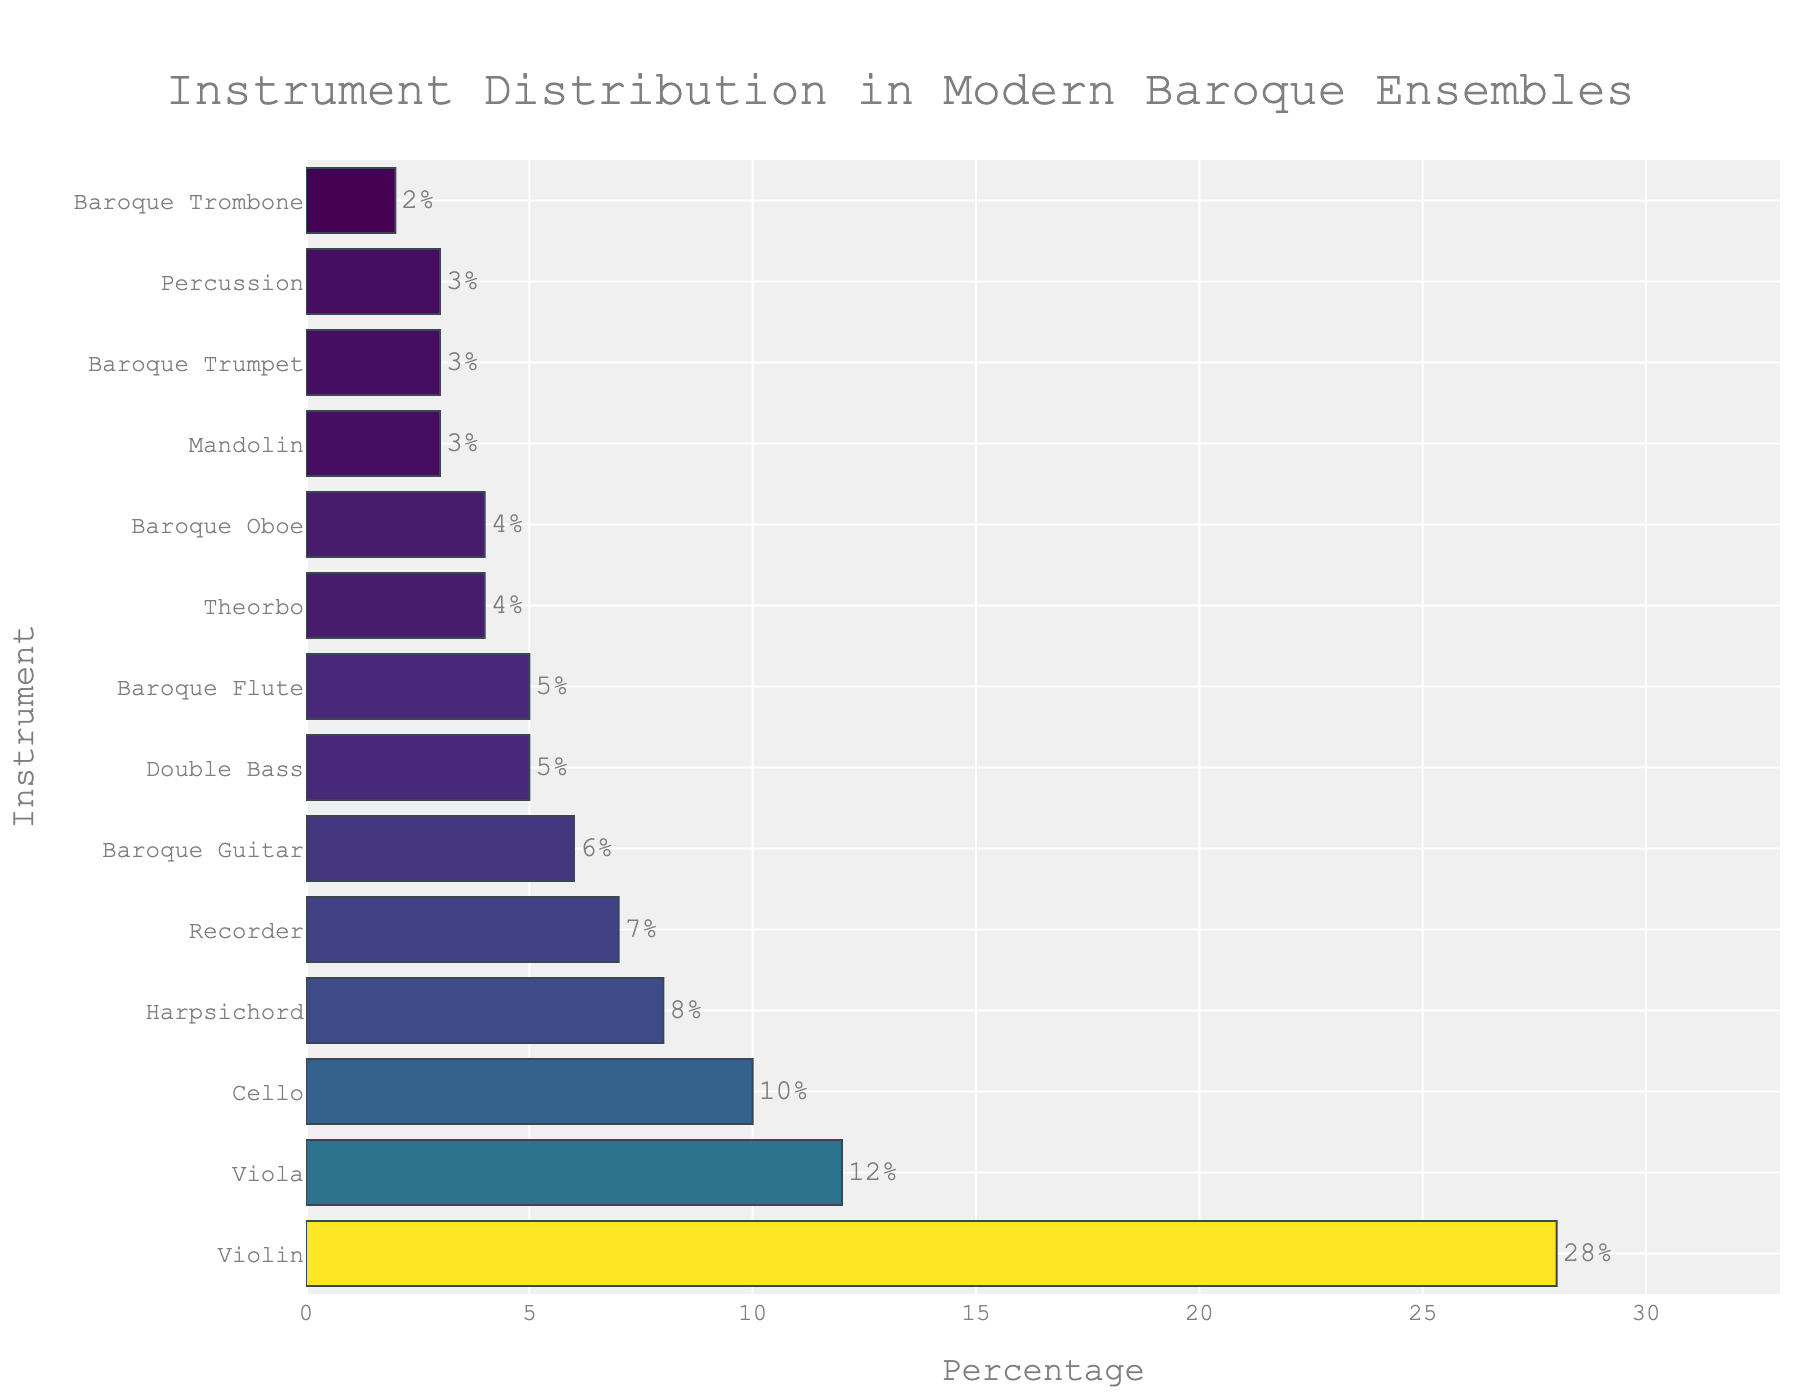What is the most common instrument in modern baroque ensembles? The most common instrument is the violin, as it has the highest percentage on the bar chart.
Answer: Violin How many instruments have a percentage greater than or equal to 10%? Identifying the instruments and their corresponding percentages from the chart, we see Violin (28%), Viola (12%), and Cello (10%) exceed or equal 10%. There are three instruments.
Answer: 3 Which instrument has the same percentage as the mandolin? The bar chart shows that the Mandolin has a percentage of 3%, and both Percussion and Baroque Trumpet share the same percentage.
Answer: Percussion and Baroque Trumpet How many instruments have a lower percentage than the Baroque Guitar? The Baroque Guitar has a percentage of 6%. Instruments with lower percentages include Theorbo (4%), Baroque Oboe (4%), Mandolin (3%), Baroque Trumpet (3%), and Baroque Trombone (2%). There are five instruments.
Answer: 5 What is the combined percentage of Harpsichord and Recorder? The chart shows Harpsichord with 8% and Recorder with 7%. Adding these gives 8% + 7% = 15%.
Answer: 15% Is the percentage of Cello more than double that of Recorder? The percentage of Cello is 10%. The percentage of Recorder is 7%. Double of Recorder is 7%*2 = 14%. Since 10% is less than 14%, the Cello’s percentage is not more than double that of the Recorder.
Answer: No What is the average percentage of the instruments sampled? Adding all the percentages: 28 + 12 + 10 + 5 + 8 + 6 + 4 + 7 + 5 + 4 + 3 + 3 + 2 + 3 = 100%. There are 14 instruments. So, the average percentage is 100/14 ≈ 7.14%.
Answer: 7.14% Which instrument distribution lies exactly in the middle when sorted by percentages in descending order? When sorted by percentages: Violin, Viola, Cello, Harpsichord, Recorder, Baroque Guitar, Baroque Flute, Double Bass, Theorbo, Baroque Oboe, Mandolin, Baroque Trumpet, Percussion, Baroque Trombone. The middle (7th) instrument is Baroque Flute.
Answer: Baroque Flute 